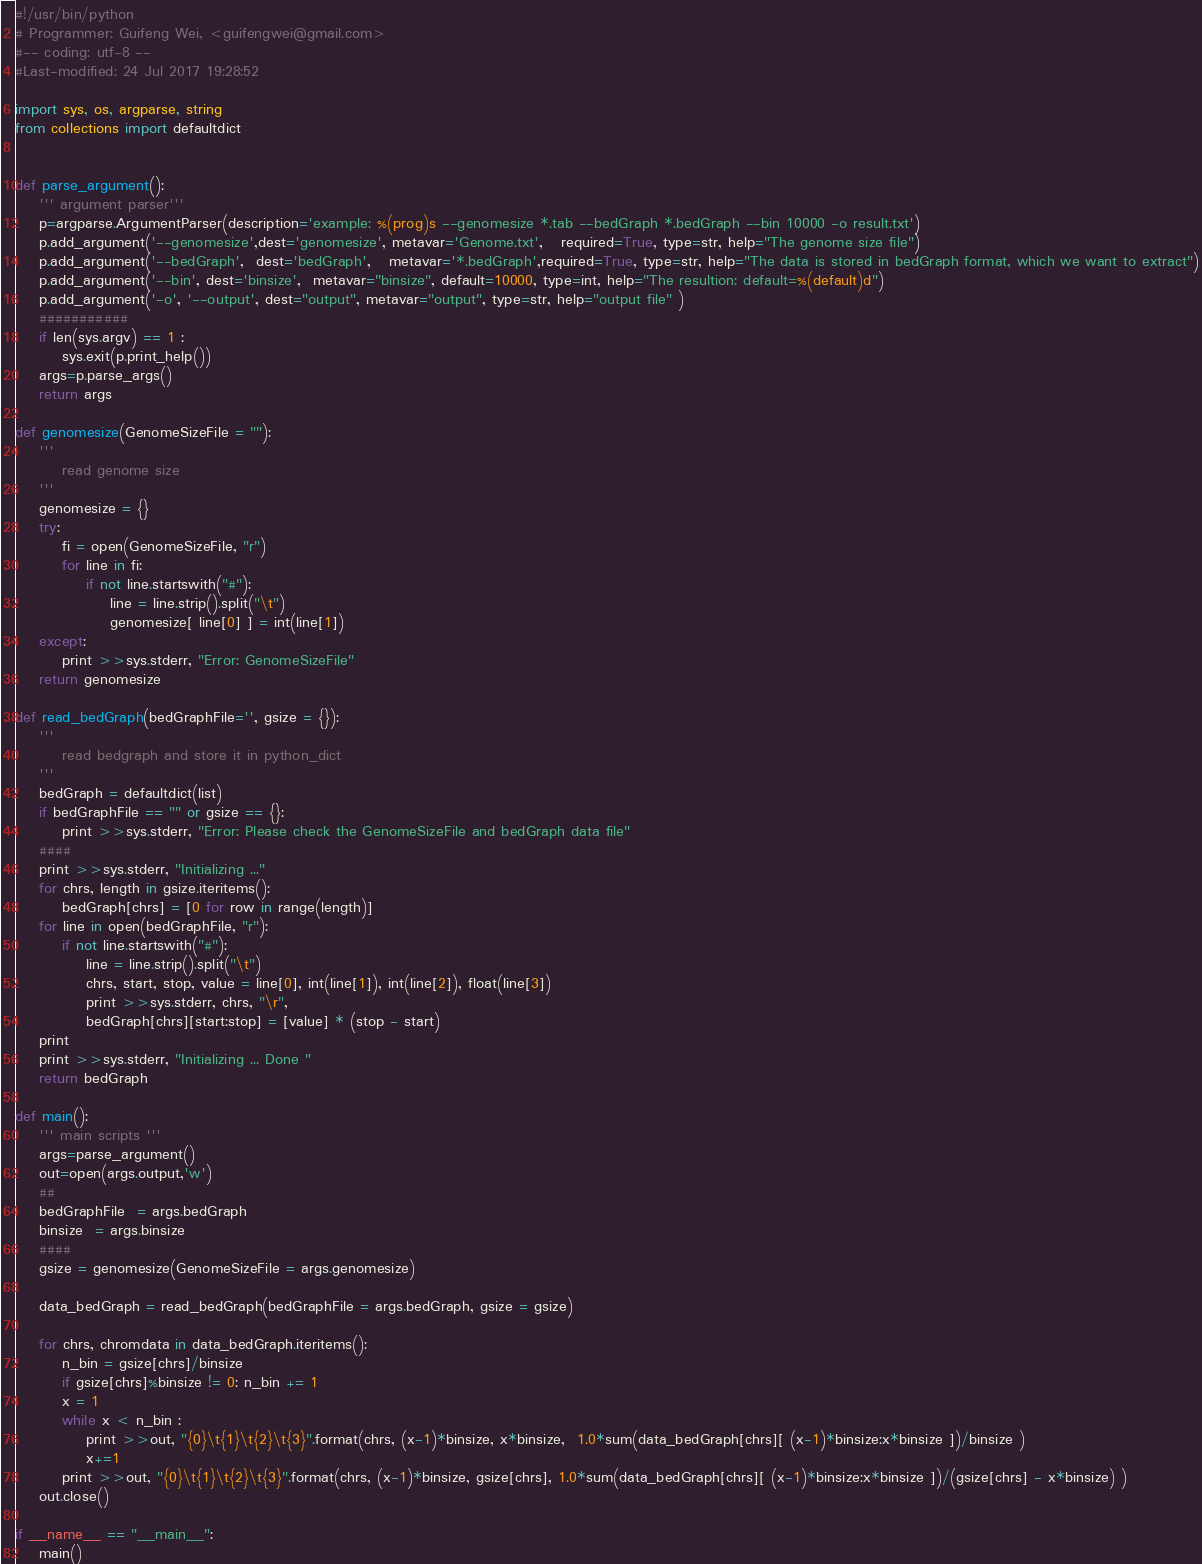Convert code to text. <code><loc_0><loc_0><loc_500><loc_500><_Python_>#!/usr/bin/python
# Programmer: Guifeng Wei, <guifengwei@gmail.com>
#-- coding: utf-8 --
#Last-modified: 24 Jul 2017 19:28:52

import sys, os, argparse, string
from collections import defaultdict


def parse_argument():
    ''' argument parser'''
    p=argparse.ArgumentParser(description='example: %(prog)s --genomesize *.tab --bedGraph *.bedGraph --bin 10000 -o result.txt')
    p.add_argument('--genomesize',dest='genomesize', metavar='Genome.txt',   required=True, type=str, help="The genome size file")
    p.add_argument('--bedGraph',  dest='bedGraph',   metavar='*.bedGraph',required=True, type=str, help="The data is stored in bedGraph format, which we want to extract")
    p.add_argument('--bin', dest='binsize',  metavar="binsize", default=10000, type=int, help="The resultion: default=%(default)d")
    p.add_argument('-o', '--output', dest="output", metavar="output", type=str, help="output file" )
    ###########
    if len(sys.argv) == 1 :
        sys.exit(p.print_help())
    args=p.parse_args()
    return args

def genomesize(GenomeSizeFile = ""):
    ''' 
        read genome size
    '''
    genomesize = {}
    try:
        fi = open(GenomeSizeFile, "r")
        for line in fi:
            if not line.startswith("#"):
                line = line.strip().split("\t")
                genomesize[ line[0] ] = int(line[1])
    except:
        print >>sys.stderr, "Error: GenomeSizeFile"
    return genomesize

def read_bedGraph(bedGraphFile='', gsize = {}):
    '''
        read bedgraph and store it in python_dict
    '''
    bedGraph = defaultdict(list)
    if bedGraphFile == "" or gsize == {}:
        print >>sys.stderr, "Error: Please check the GenomeSizeFile and bedGraph data file"
    #### 
    print >>sys.stderr, "Initializing ..."
    for chrs, length in gsize.iteritems():
        bedGraph[chrs] = [0 for row in range(length)]
    for line in open(bedGraphFile, "r"):
        if not line.startswith("#"):
            line = line.strip().split("\t")
            chrs, start, stop, value = line[0], int(line[1]), int(line[2]), float(line[3])
            print >>sys.stderr, chrs, "\r",
            bedGraph[chrs][start:stop] = [value] * (stop - start)
    print 
    print >>sys.stderr, "Initializing ... Done "
    return bedGraph

def main():
    ''' main scripts '''
    args=parse_argument()
    out=open(args.output,'w')
    ##
    bedGraphFile  = args.bedGraph
    binsize  = args.binsize
    ####
    gsize = genomesize(GenomeSizeFile = args.genomesize)
    
    data_bedGraph = read_bedGraph(bedGraphFile = args.bedGraph, gsize = gsize)

    for chrs, chromdata in data_bedGraph.iteritems():
        n_bin = gsize[chrs]/binsize
        if gsize[chrs]%binsize != 0: n_bin += 1
        x = 1
        while x < n_bin :
            print >>out, "{0}\t{1}\t{2}\t{3}".format(chrs, (x-1)*binsize, x*binsize,  1.0*sum(data_bedGraph[chrs][ (x-1)*binsize:x*binsize ])/binsize )
            x+=1
        print >>out, "{0}\t{1}\t{2}\t{3}".format(chrs, (x-1)*binsize, gsize[chrs], 1.0*sum(data_bedGraph[chrs][ (x-1)*binsize:x*binsize ])/(gsize[chrs] - x*binsize) )
    out.close()

if __name__ == "__main__":
    main()
</code> 